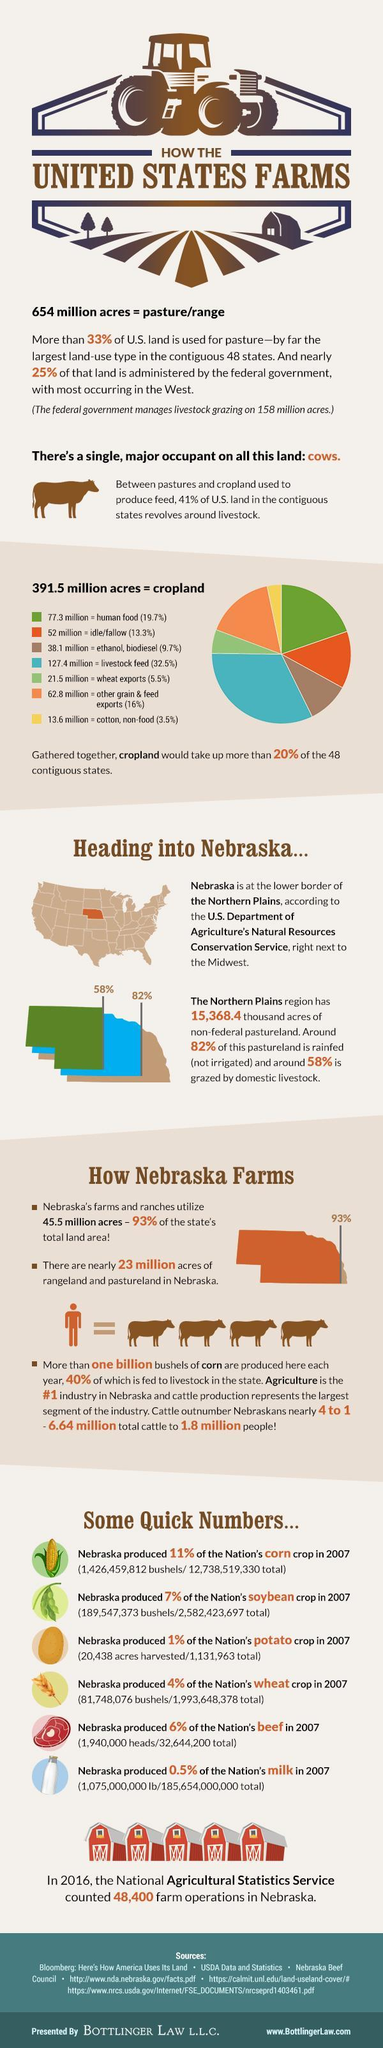What is total contribution percentage by Nebraska in corn and soybean crop
Answer the question with a short phrase. 18 What contributes to 16% of the cropland, human food, other grain & feed exports, or livestock feed? other grain & feed exports Which item occupies the larger acreage in the  cropland  among human food,  idle, or wheat exports? human food what  type of cropland is occupied in orange colour idle/fallow How many components gathered together in the cropland? 7 What  percentage of pasture land and is not administered by the federal government ? 8% 